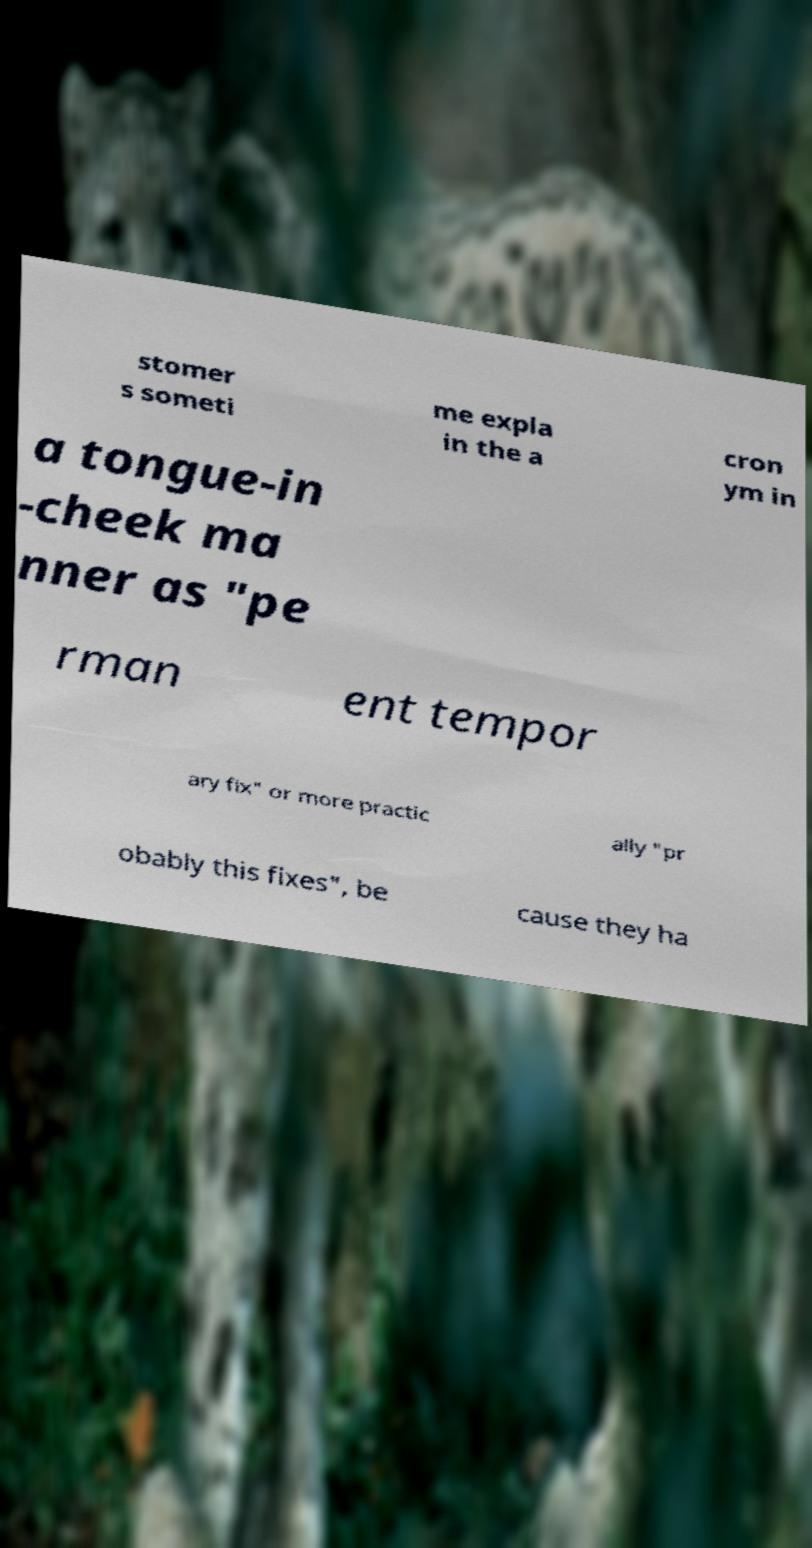Could you extract and type out the text from this image? stomer s someti me expla in the a cron ym in a tongue-in -cheek ma nner as "pe rman ent tempor ary fix" or more practic ally "pr obably this fixes", be cause they ha 